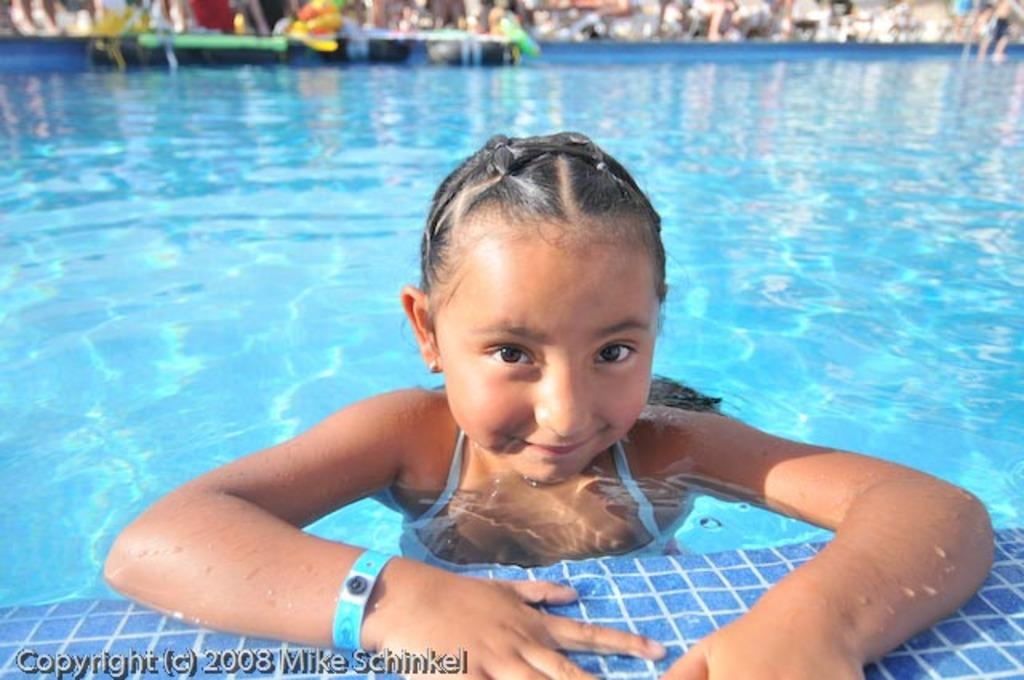What is the main subject of the image? There is a girl in the swimming pool. What is the girl's expression in the image? The girl is smiling. Can you describe the background of the image? The background of the image is blurred. Is there any additional information or markings on the image? Yes, there is a watermark on the image. What type of apple is being used as a flotation device in the image? There is no apple present in the image, and therefore it cannot be used as a flotation device. 